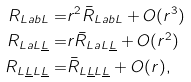<formula> <loc_0><loc_0><loc_500><loc_500>R _ { L a b L } = & r ^ { 2 } \bar { R } _ { L a b L } + O ( r ^ { 3 } ) \\ R _ { L a L \underline { L } } = & r \bar { R } _ { L a L \underline { L } } + O ( r ^ { 2 } ) \\ R _ { L \underline { L } L \underline { L } } = & \bar { R } _ { L \underline { L } L \underline { L } } + O ( r ) ,</formula> 